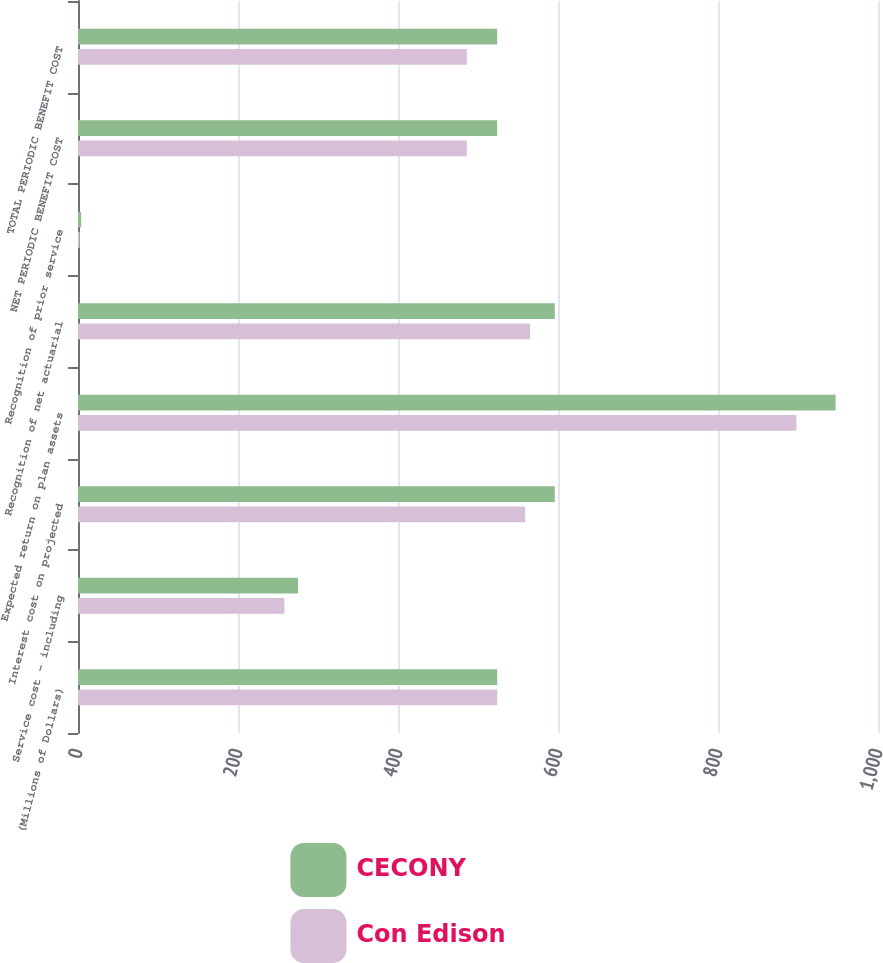Convert chart. <chart><loc_0><loc_0><loc_500><loc_500><stacked_bar_chart><ecel><fcel>(Millions of Dollars)<fcel>Service cost - including<fcel>Interest cost on projected<fcel>Expected return on plan assets<fcel>Recognition of net actuarial<fcel>Recognition of prior service<fcel>NET PERIODIC BENEFIT COST<fcel>TOTAL PERIODIC BENEFIT COST<nl><fcel>CECONY<fcel>524<fcel>275<fcel>596<fcel>947<fcel>596<fcel>4<fcel>524<fcel>524<nl><fcel>Con Edison<fcel>524<fcel>258<fcel>559<fcel>898<fcel>565<fcel>2<fcel>486<fcel>486<nl></chart> 